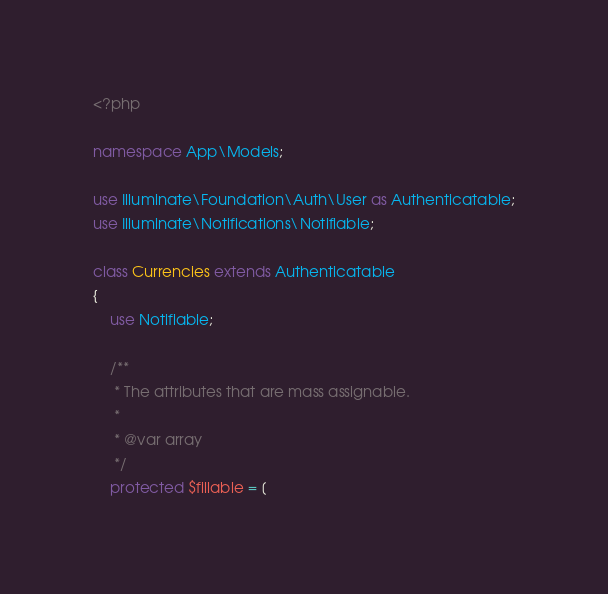<code> <loc_0><loc_0><loc_500><loc_500><_PHP_><?php

namespace App\Models;

use Illuminate\Foundation\Auth\User as Authenticatable;
use Illuminate\Notifications\Notifiable;

class Currencies extends Authenticatable
{
    use Notifiable;

    /**
     * The attributes that are mass assignable.
     *
     * @var array
     */
    protected $fillable = [</code> 